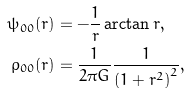Convert formula to latex. <formula><loc_0><loc_0><loc_500><loc_500>\psi _ { 0 0 } ( r ) & = - \frac { 1 } { r } \arctan r , \\ \rho _ { 0 0 } ( r ) & = \frac { 1 } { 2 \pi G } \frac { 1 } { \left ( 1 + r ^ { 2 } \right ) ^ { 2 } } ,</formula> 